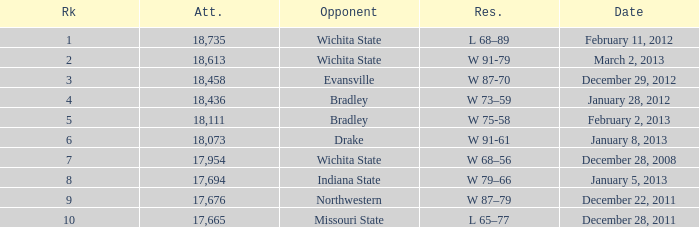What's the rank for February 11, 2012 with less than 18,735 in attendance? None. 